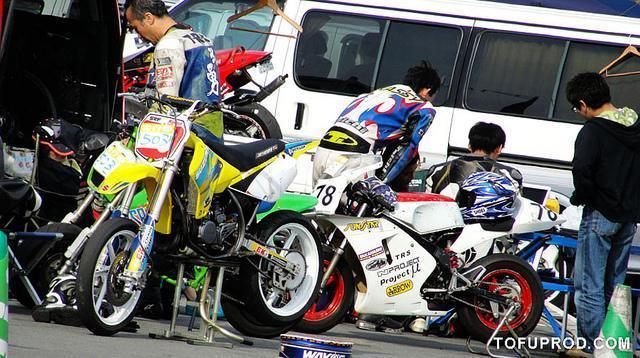How many motorcycles are in the picture?
Give a very brief answer. 2. How many people can you see?
Give a very brief answer. 4. How many boats are shown?
Give a very brief answer. 0. 